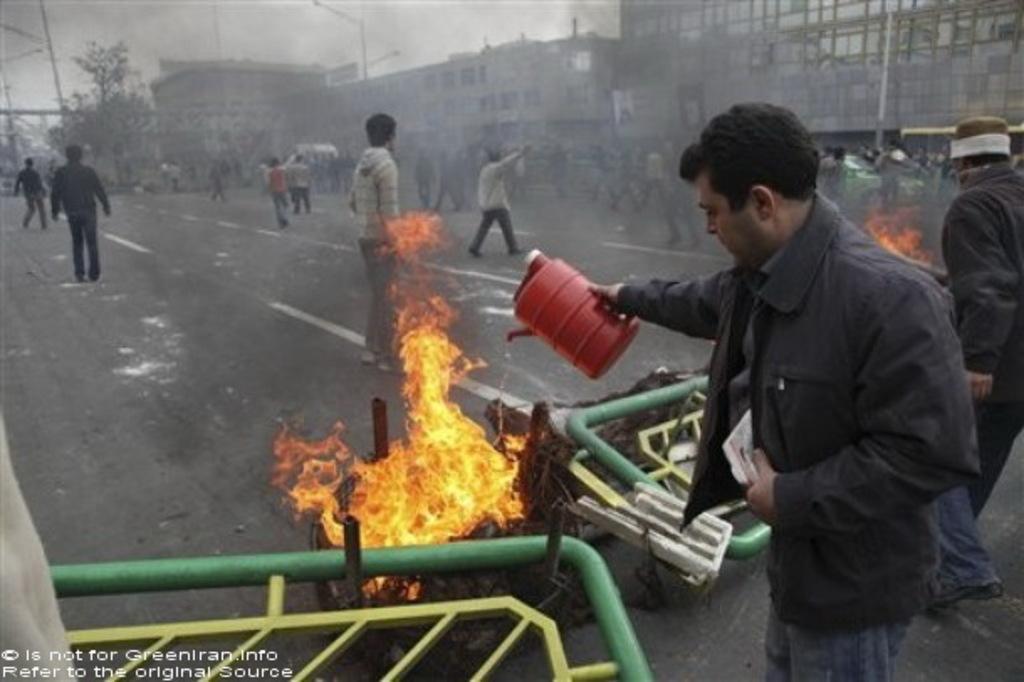Can you describe this image briefly? At the bottom left of the image there is a green color stand on the floor. And at the right side of the image there is a man with black dress is standing and holding the red can in his hand. In front of him on the road there is a fire. On the in the background there are few people standing and also there is smoke. Also in the background there are buildings with walls and glass windows. And to the top of the image there is a sky. 